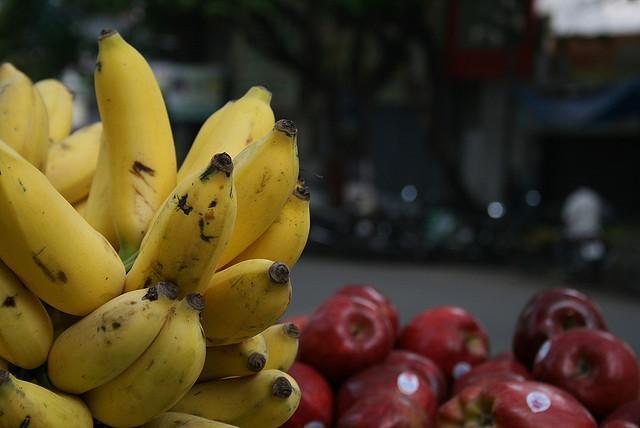How many types of fruit are shown?
Give a very brief answer. 2. How many apples are there?
Give a very brief answer. 2. 